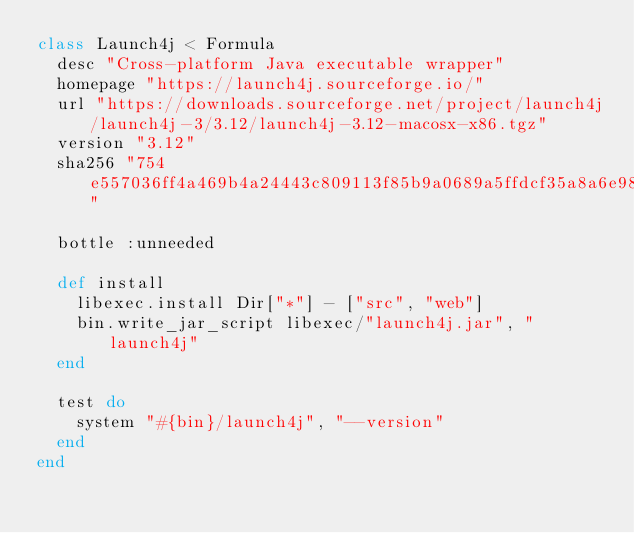Convert code to text. <code><loc_0><loc_0><loc_500><loc_500><_Ruby_>class Launch4j < Formula
  desc "Cross-platform Java executable wrapper"
  homepage "https://launch4j.sourceforge.io/"
  url "https://downloads.sourceforge.net/project/launch4j/launch4j-3/3.12/launch4j-3.12-macosx-x86.tgz"
  version "3.12"
  sha256 "754e557036ff4a469b4a24443c809113f85b9a0689a5ffdcf35a8a6e986c458f"

  bottle :unneeded

  def install
    libexec.install Dir["*"] - ["src", "web"]
    bin.write_jar_script libexec/"launch4j.jar", "launch4j"
  end

  test do
    system "#{bin}/launch4j", "--version"
  end
end
</code> 